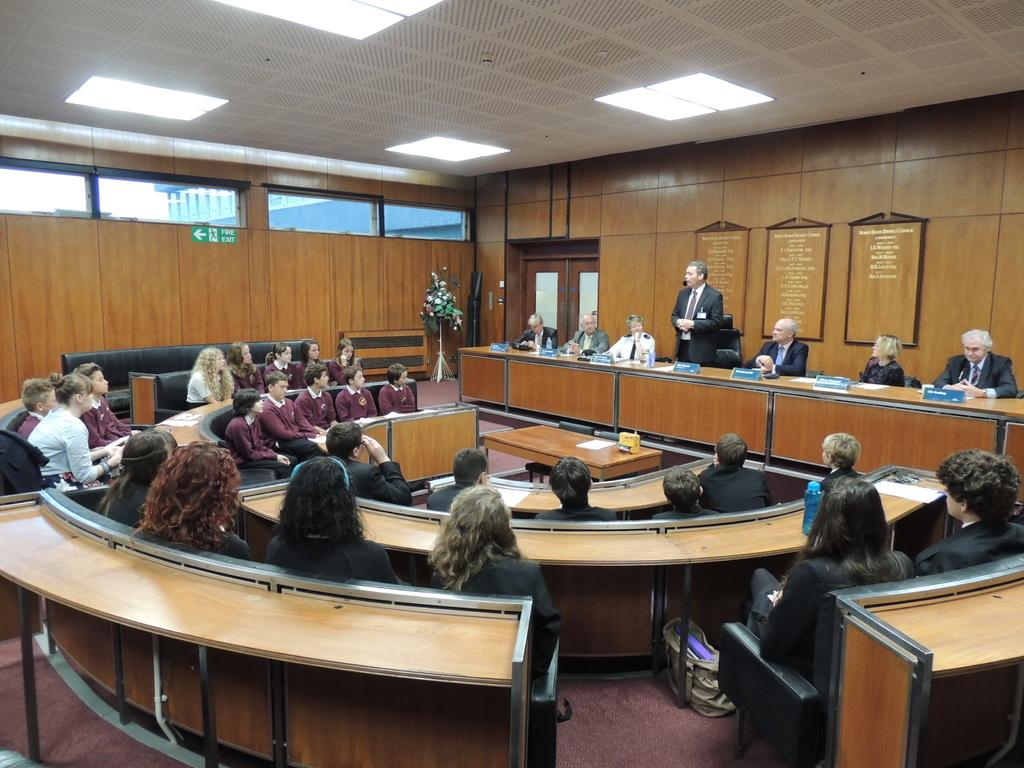What type of space is shown in the image? The image depicts a hall. What material is used for the walls and roof of the hall? The hall has wooden walls and roof. Are there any light sources in the hall? Yes, there are lights in the hall. How many people are present in the hall? There are many people, both male and female, in the hall. What type of furniture is available in the hall? There are tables with chairs in the hall. Can you spot any decorative items in the hall? Yes, there is a flower vase in the hall. How many servants are attending to the guests in the hall? There is no mention of servants in the image, so it is not possible to determine their presence or number. What type of artwork is hanging on the walls of the hall? The image does not show any artwork on the walls; it only depicts wooden walls and roof. 